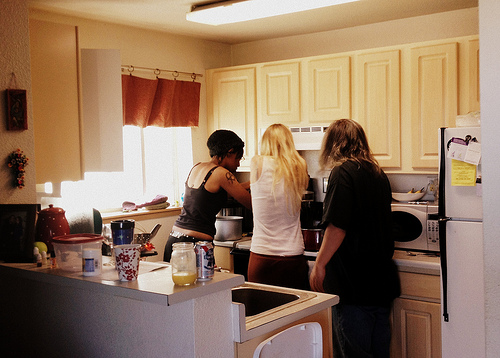<image>
Can you confirm if the women is to the left of the women? Yes. From this viewpoint, the women is positioned to the left side relative to the women. 